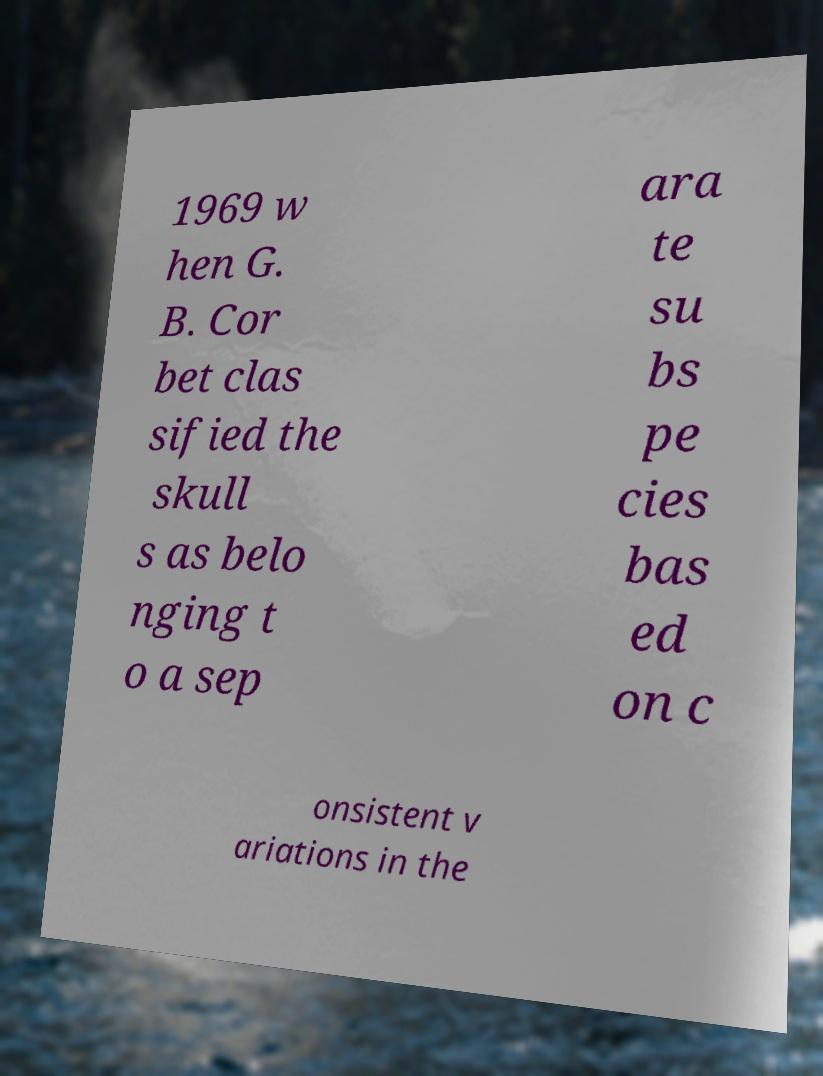Could you assist in decoding the text presented in this image and type it out clearly? 1969 w hen G. B. Cor bet clas sified the skull s as belo nging t o a sep ara te su bs pe cies bas ed on c onsistent v ariations in the 